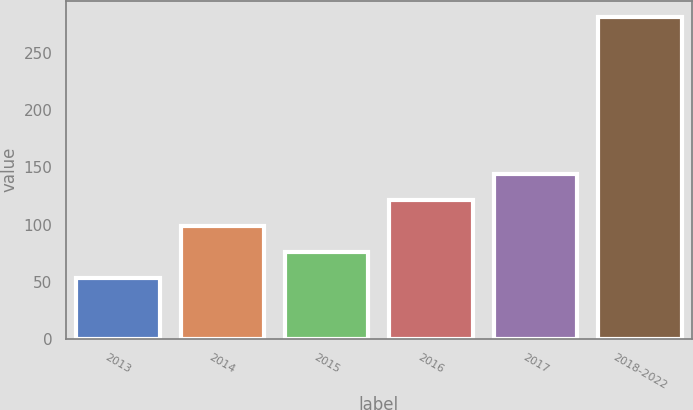<chart> <loc_0><loc_0><loc_500><loc_500><bar_chart><fcel>2013<fcel>2014<fcel>2015<fcel>2016<fcel>2017<fcel>2018-2022<nl><fcel>53<fcel>98.8<fcel>75.9<fcel>121.7<fcel>144.6<fcel>282<nl></chart> 